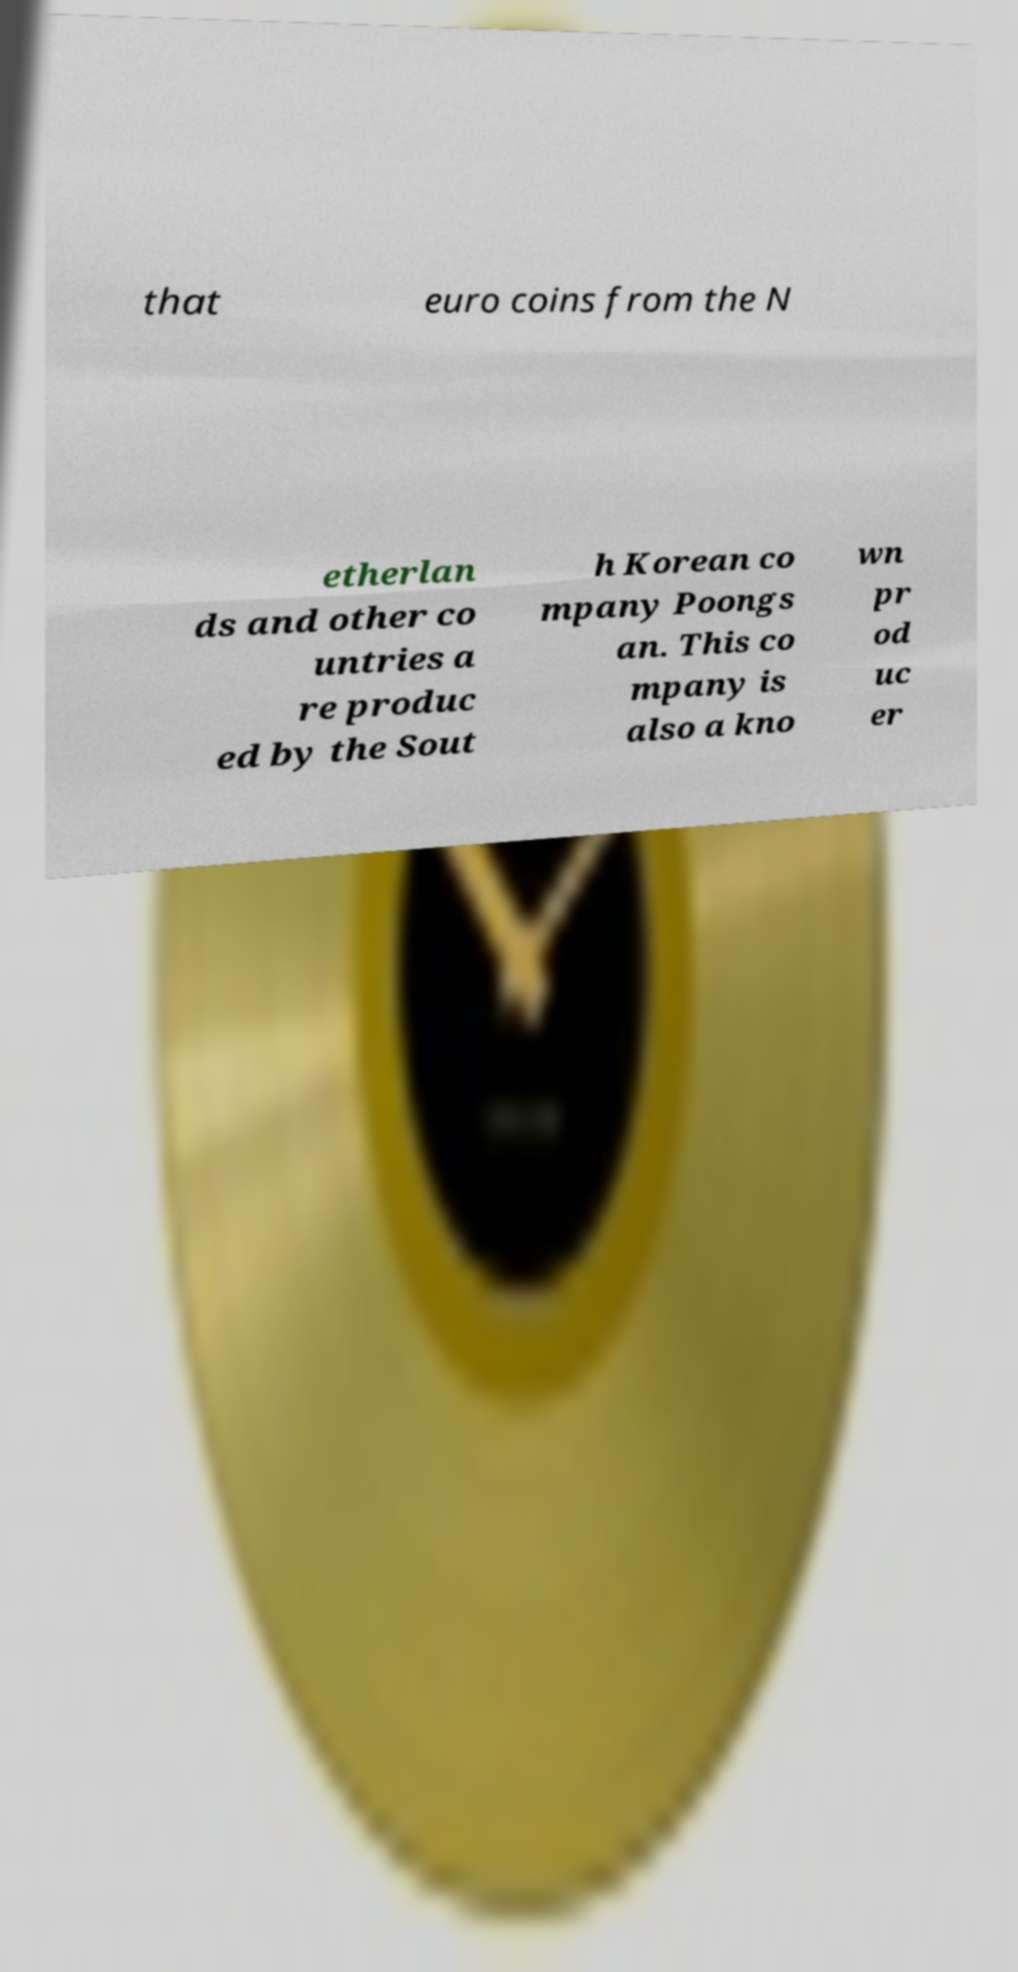Could you extract and type out the text from this image? that euro coins from the N etherlan ds and other co untries a re produc ed by the Sout h Korean co mpany Poongs an. This co mpany is also a kno wn pr od uc er 